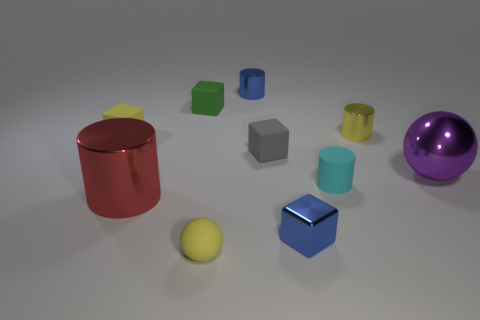Subtract all cylinders. How many objects are left? 6 Add 5 cyan objects. How many cyan objects exist? 6 Subtract 1 yellow blocks. How many objects are left? 9 Subtract all red metallic balls. Subtract all yellow cubes. How many objects are left? 9 Add 3 rubber cylinders. How many rubber cylinders are left? 4 